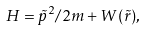<formula> <loc_0><loc_0><loc_500><loc_500>H = \tilde { p } ^ { 2 } / 2 m + W ( \tilde { r } ) ,</formula> 